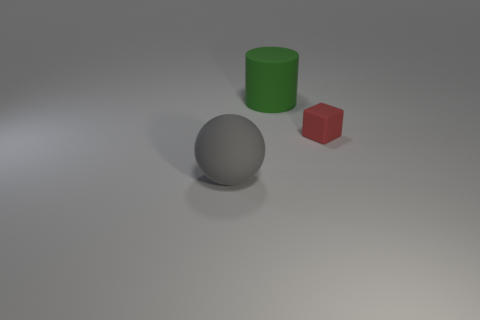Subtract all brown spheres. Subtract all gray cylinders. How many spheres are left? 1 Add 1 brown shiny cubes. How many objects exist? 4 Subtract all gray spheres. Subtract all large gray matte objects. How many objects are left? 1 Add 2 gray balls. How many gray balls are left? 3 Add 3 green things. How many green things exist? 4 Subtract 0 blue cubes. How many objects are left? 3 Subtract all cubes. How many objects are left? 2 